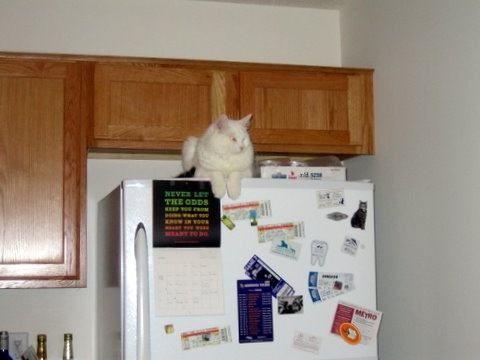Describe the objects in this image and their specific colors. I can see refrigerator in darkgray, lightgray, black, and gray tones, cat in darkgray, tan, and gray tones, bottle in darkgray, black, gray, and navy tones, bottle in darkgray, black, olive, and gray tones, and bottle in darkgray, gray, ivory, and darkgreen tones in this image. 